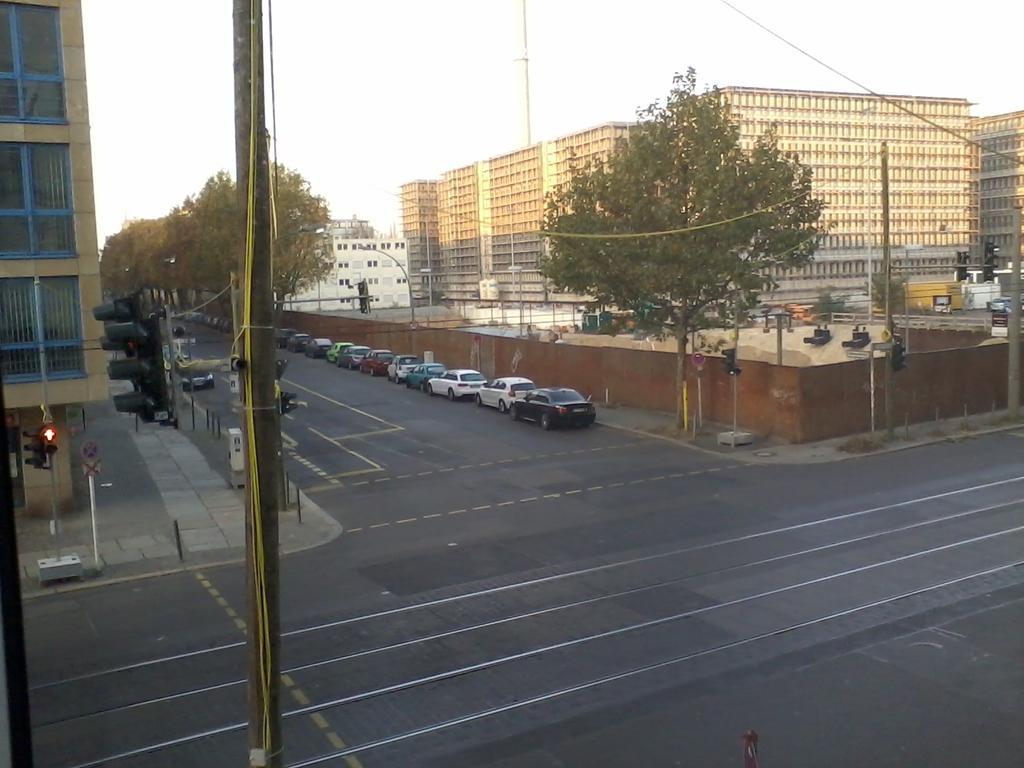In one or two sentences, can you explain what this image depicts? This picture is clicked outside the city. At the bottom of the picture, we see the road. On the left side, we see the pole, traffic signals and a board. We see a building. In the middle of the picture, we see the cars parked on the road. There are trees and buildings in the background. We even see the poles and street lights. At the top, we see the sky. 